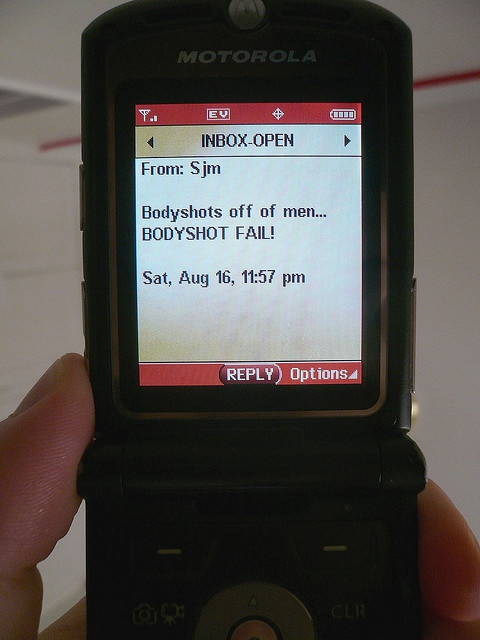Describe the objects in this image and their specific colors. I can see cell phone in black, gray, lightgray, lightblue, and darkgray tones and people in gray, maroon, black, and brown tones in this image. 